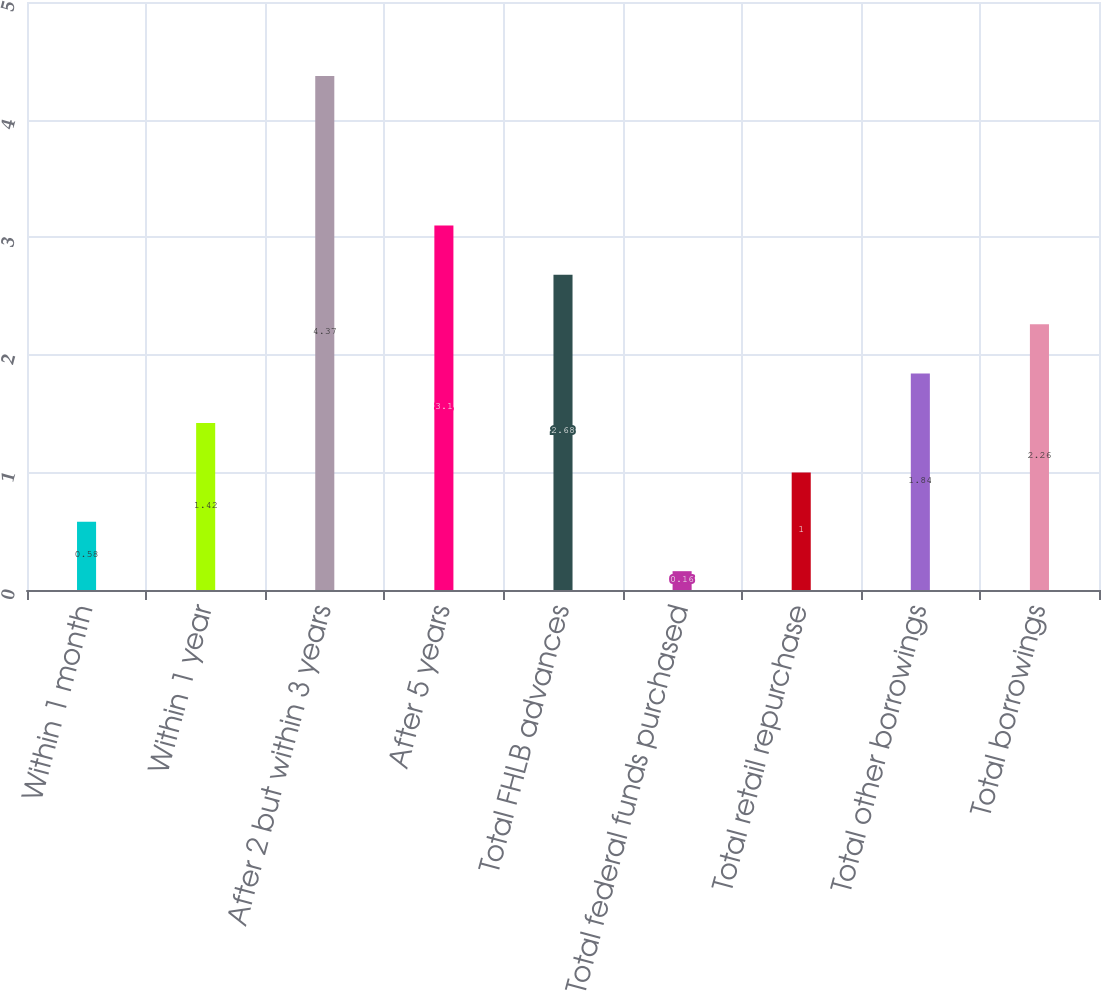<chart> <loc_0><loc_0><loc_500><loc_500><bar_chart><fcel>Within 1 month<fcel>Within 1 year<fcel>After 2 but within 3 years<fcel>After 5 years<fcel>Total FHLB advances<fcel>Total federal funds purchased<fcel>Total retail repurchase<fcel>Total other borrowings<fcel>Total borrowings<nl><fcel>0.58<fcel>1.42<fcel>4.37<fcel>3.1<fcel>2.68<fcel>0.16<fcel>1<fcel>1.84<fcel>2.26<nl></chart> 